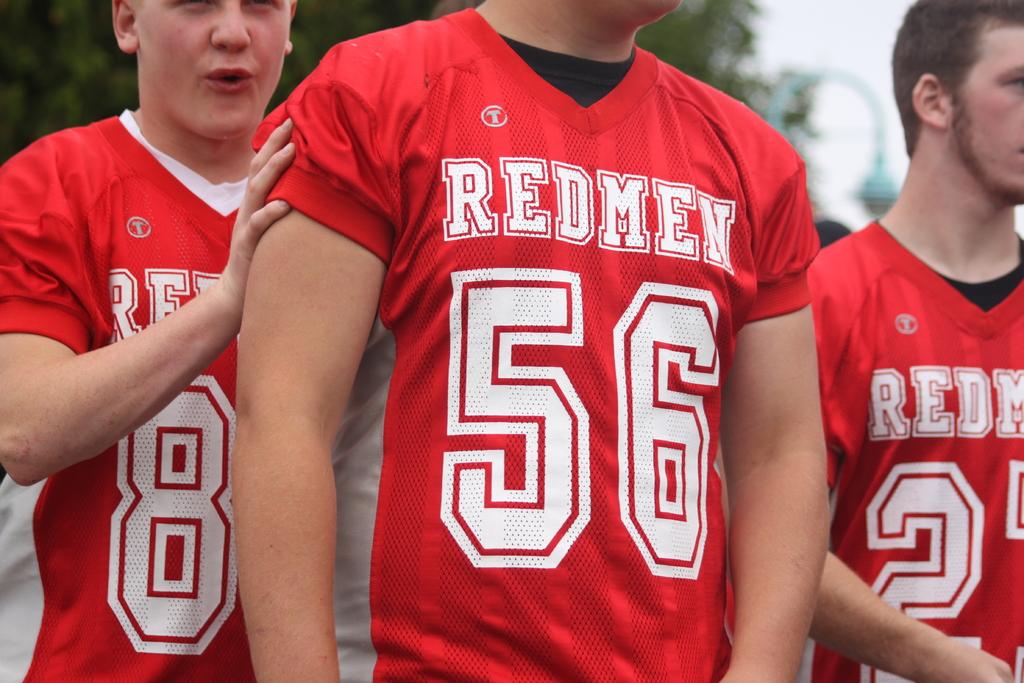What team name is shown on the jersey?
Your answer should be very brief. Redmen. 